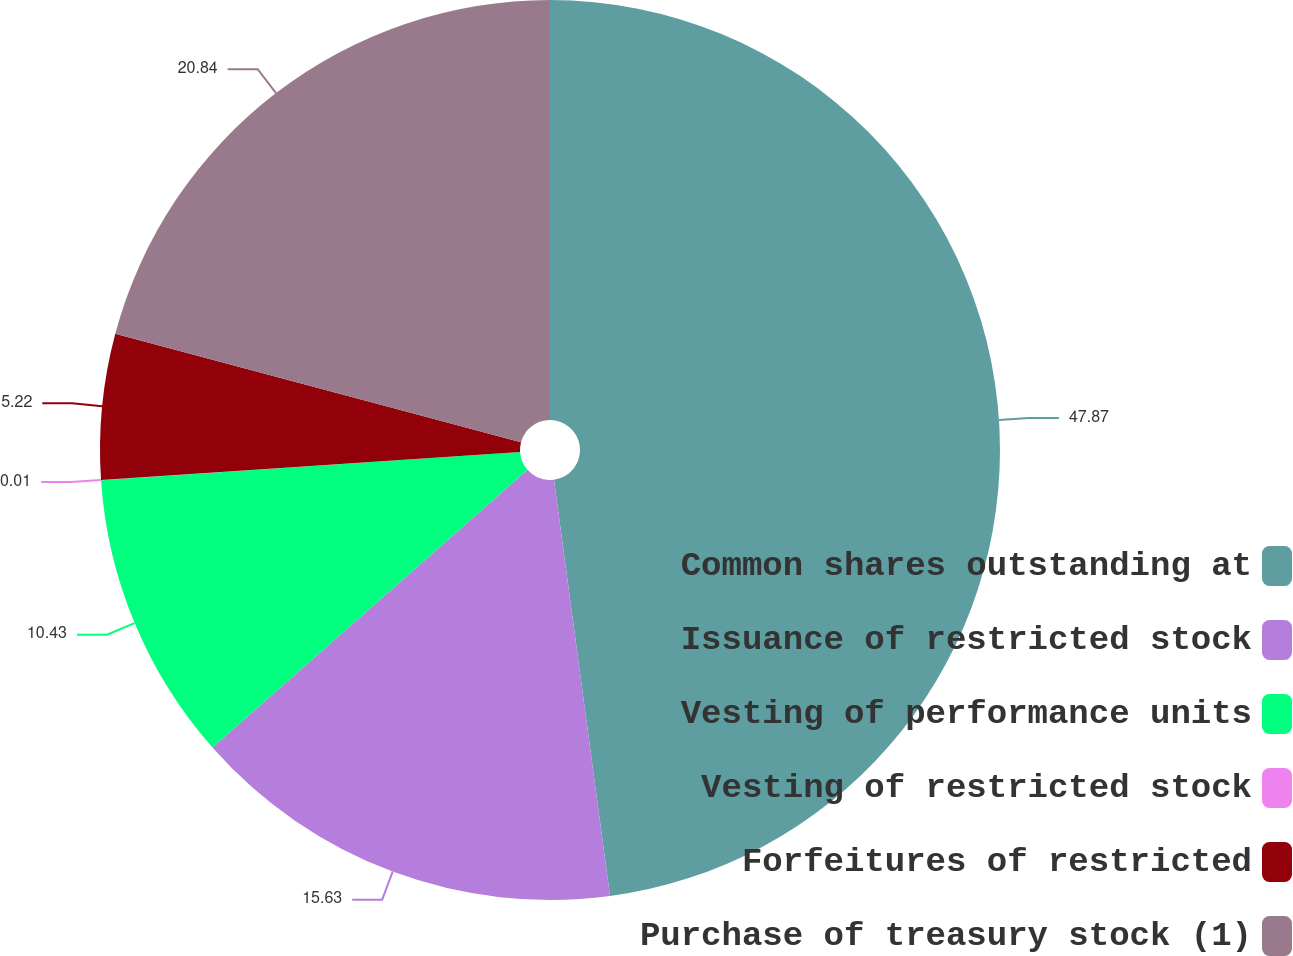<chart> <loc_0><loc_0><loc_500><loc_500><pie_chart><fcel>Common shares outstanding at<fcel>Issuance of restricted stock<fcel>Vesting of performance units<fcel>Vesting of restricted stock<fcel>Forfeitures of restricted<fcel>Purchase of treasury stock (1)<nl><fcel>47.87%<fcel>15.63%<fcel>10.43%<fcel>0.01%<fcel>5.22%<fcel>20.84%<nl></chart> 